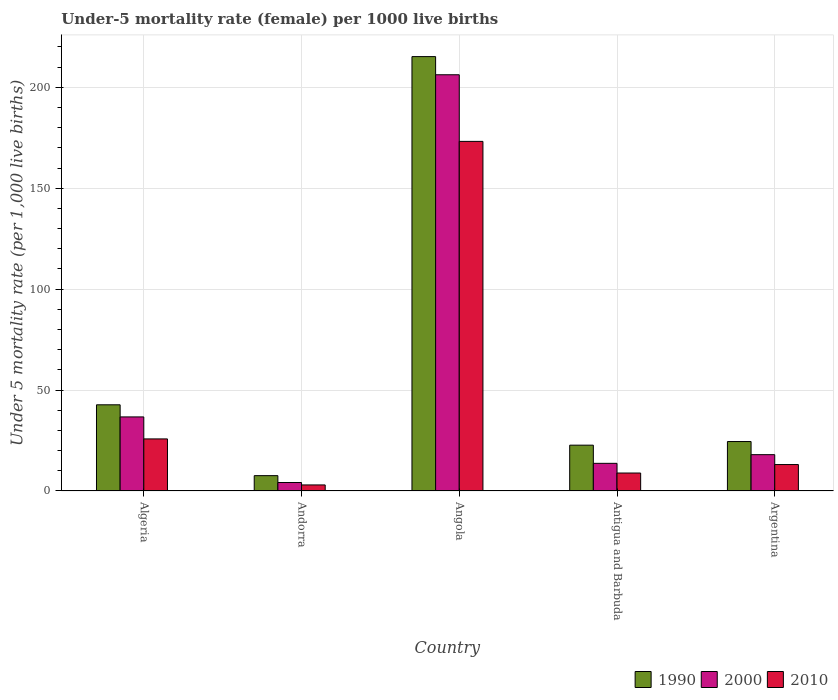How many groups of bars are there?
Provide a succinct answer. 5. How many bars are there on the 4th tick from the right?
Your response must be concise. 3. What is the label of the 3rd group of bars from the left?
Provide a short and direct response. Angola. What is the under-five mortality rate in 2000 in Angola?
Ensure brevity in your answer.  206.2. Across all countries, what is the maximum under-five mortality rate in 2000?
Make the answer very short. 206.2. Across all countries, what is the minimum under-five mortality rate in 1990?
Offer a terse response. 7.6. In which country was the under-five mortality rate in 2000 maximum?
Offer a terse response. Angola. In which country was the under-five mortality rate in 2000 minimum?
Provide a short and direct response. Andorra. What is the total under-five mortality rate in 1990 in the graph?
Provide a succinct answer. 312.7. What is the difference between the under-five mortality rate in 2010 in Andorra and that in Angola?
Your answer should be compact. -170.2. What is the difference between the under-five mortality rate in 1990 in Andorra and the under-five mortality rate in 2000 in Angola?
Keep it short and to the point. -198.6. What is the average under-five mortality rate in 2000 per country?
Keep it short and to the point. 55.76. What is the difference between the under-five mortality rate of/in 1990 and under-five mortality rate of/in 2010 in Algeria?
Your answer should be compact. 16.9. In how many countries, is the under-five mortality rate in 2010 greater than 170?
Offer a terse response. 1. What is the ratio of the under-five mortality rate in 2000 in Antigua and Barbuda to that in Argentina?
Offer a very short reply. 0.76. Is the difference between the under-five mortality rate in 1990 in Andorra and Antigua and Barbuda greater than the difference between the under-five mortality rate in 2010 in Andorra and Antigua and Barbuda?
Provide a succinct answer. No. What is the difference between the highest and the second highest under-five mortality rate in 2000?
Make the answer very short. -18.7. What is the difference between the highest and the lowest under-five mortality rate in 2010?
Your response must be concise. 170.2. Is the sum of the under-five mortality rate in 1990 in Antigua and Barbuda and Argentina greater than the maximum under-five mortality rate in 2010 across all countries?
Your response must be concise. No. What does the 1st bar from the right in Argentina represents?
Offer a terse response. 2010. Is it the case that in every country, the sum of the under-five mortality rate in 1990 and under-five mortality rate in 2010 is greater than the under-five mortality rate in 2000?
Offer a terse response. Yes. How many bars are there?
Your answer should be compact. 15. How many countries are there in the graph?
Offer a terse response. 5. Where does the legend appear in the graph?
Your answer should be very brief. Bottom right. How are the legend labels stacked?
Provide a short and direct response. Horizontal. What is the title of the graph?
Make the answer very short. Under-5 mortality rate (female) per 1000 live births. Does "1999" appear as one of the legend labels in the graph?
Provide a short and direct response. No. What is the label or title of the Y-axis?
Offer a terse response. Under 5 mortality rate (per 1,0 live births). What is the Under 5 mortality rate (per 1,000 live births) of 1990 in Algeria?
Offer a terse response. 42.7. What is the Under 5 mortality rate (per 1,000 live births) in 2000 in Algeria?
Ensure brevity in your answer.  36.7. What is the Under 5 mortality rate (per 1,000 live births) of 2010 in Algeria?
Offer a very short reply. 25.8. What is the Under 5 mortality rate (per 1,000 live births) of 1990 in Andorra?
Offer a terse response. 7.6. What is the Under 5 mortality rate (per 1,000 live births) in 2010 in Andorra?
Your answer should be compact. 3. What is the Under 5 mortality rate (per 1,000 live births) of 1990 in Angola?
Give a very brief answer. 215.2. What is the Under 5 mortality rate (per 1,000 live births) in 2000 in Angola?
Offer a terse response. 206.2. What is the Under 5 mortality rate (per 1,000 live births) in 2010 in Angola?
Your answer should be compact. 173.2. What is the Under 5 mortality rate (per 1,000 live births) in 1990 in Antigua and Barbuda?
Your response must be concise. 22.7. What is the Under 5 mortality rate (per 1,000 live births) in 2000 in Antigua and Barbuda?
Ensure brevity in your answer.  13.7. What is the Under 5 mortality rate (per 1,000 live births) of 2010 in Antigua and Barbuda?
Give a very brief answer. 8.9. What is the Under 5 mortality rate (per 1,000 live births) of 1990 in Argentina?
Provide a short and direct response. 24.5. What is the Under 5 mortality rate (per 1,000 live births) in 2000 in Argentina?
Provide a short and direct response. 18. Across all countries, what is the maximum Under 5 mortality rate (per 1,000 live births) in 1990?
Provide a succinct answer. 215.2. Across all countries, what is the maximum Under 5 mortality rate (per 1,000 live births) of 2000?
Your response must be concise. 206.2. Across all countries, what is the maximum Under 5 mortality rate (per 1,000 live births) of 2010?
Offer a terse response. 173.2. Across all countries, what is the minimum Under 5 mortality rate (per 1,000 live births) in 1990?
Provide a succinct answer. 7.6. Across all countries, what is the minimum Under 5 mortality rate (per 1,000 live births) of 2000?
Offer a terse response. 4.2. Across all countries, what is the minimum Under 5 mortality rate (per 1,000 live births) in 2010?
Your answer should be compact. 3. What is the total Under 5 mortality rate (per 1,000 live births) of 1990 in the graph?
Make the answer very short. 312.7. What is the total Under 5 mortality rate (per 1,000 live births) of 2000 in the graph?
Provide a succinct answer. 278.8. What is the total Under 5 mortality rate (per 1,000 live births) in 2010 in the graph?
Offer a very short reply. 224. What is the difference between the Under 5 mortality rate (per 1,000 live births) of 1990 in Algeria and that in Andorra?
Offer a very short reply. 35.1. What is the difference between the Under 5 mortality rate (per 1,000 live births) in 2000 in Algeria and that in Andorra?
Provide a short and direct response. 32.5. What is the difference between the Under 5 mortality rate (per 1,000 live births) in 2010 in Algeria and that in Andorra?
Your answer should be compact. 22.8. What is the difference between the Under 5 mortality rate (per 1,000 live births) of 1990 in Algeria and that in Angola?
Your answer should be very brief. -172.5. What is the difference between the Under 5 mortality rate (per 1,000 live births) of 2000 in Algeria and that in Angola?
Offer a very short reply. -169.5. What is the difference between the Under 5 mortality rate (per 1,000 live births) in 2010 in Algeria and that in Angola?
Make the answer very short. -147.4. What is the difference between the Under 5 mortality rate (per 1,000 live births) in 1990 in Algeria and that in Antigua and Barbuda?
Provide a succinct answer. 20. What is the difference between the Under 5 mortality rate (per 1,000 live births) of 2000 in Algeria and that in Antigua and Barbuda?
Offer a very short reply. 23. What is the difference between the Under 5 mortality rate (per 1,000 live births) of 1990 in Algeria and that in Argentina?
Your answer should be very brief. 18.2. What is the difference between the Under 5 mortality rate (per 1,000 live births) of 2000 in Algeria and that in Argentina?
Provide a succinct answer. 18.7. What is the difference between the Under 5 mortality rate (per 1,000 live births) of 1990 in Andorra and that in Angola?
Offer a very short reply. -207.6. What is the difference between the Under 5 mortality rate (per 1,000 live births) in 2000 in Andorra and that in Angola?
Make the answer very short. -202. What is the difference between the Under 5 mortality rate (per 1,000 live births) of 2010 in Andorra and that in Angola?
Give a very brief answer. -170.2. What is the difference between the Under 5 mortality rate (per 1,000 live births) in 1990 in Andorra and that in Antigua and Barbuda?
Offer a very short reply. -15.1. What is the difference between the Under 5 mortality rate (per 1,000 live births) of 1990 in Andorra and that in Argentina?
Keep it short and to the point. -16.9. What is the difference between the Under 5 mortality rate (per 1,000 live births) in 2000 in Andorra and that in Argentina?
Make the answer very short. -13.8. What is the difference between the Under 5 mortality rate (per 1,000 live births) of 1990 in Angola and that in Antigua and Barbuda?
Your response must be concise. 192.5. What is the difference between the Under 5 mortality rate (per 1,000 live births) of 2000 in Angola and that in Antigua and Barbuda?
Give a very brief answer. 192.5. What is the difference between the Under 5 mortality rate (per 1,000 live births) in 2010 in Angola and that in Antigua and Barbuda?
Provide a succinct answer. 164.3. What is the difference between the Under 5 mortality rate (per 1,000 live births) of 1990 in Angola and that in Argentina?
Ensure brevity in your answer.  190.7. What is the difference between the Under 5 mortality rate (per 1,000 live births) of 2000 in Angola and that in Argentina?
Your response must be concise. 188.2. What is the difference between the Under 5 mortality rate (per 1,000 live births) of 2010 in Angola and that in Argentina?
Your answer should be very brief. 160.1. What is the difference between the Under 5 mortality rate (per 1,000 live births) in 1990 in Antigua and Barbuda and that in Argentina?
Keep it short and to the point. -1.8. What is the difference between the Under 5 mortality rate (per 1,000 live births) of 2010 in Antigua and Barbuda and that in Argentina?
Your answer should be very brief. -4.2. What is the difference between the Under 5 mortality rate (per 1,000 live births) of 1990 in Algeria and the Under 5 mortality rate (per 1,000 live births) of 2000 in Andorra?
Ensure brevity in your answer.  38.5. What is the difference between the Under 5 mortality rate (per 1,000 live births) in 1990 in Algeria and the Under 5 mortality rate (per 1,000 live births) in 2010 in Andorra?
Offer a very short reply. 39.7. What is the difference between the Under 5 mortality rate (per 1,000 live births) of 2000 in Algeria and the Under 5 mortality rate (per 1,000 live births) of 2010 in Andorra?
Keep it short and to the point. 33.7. What is the difference between the Under 5 mortality rate (per 1,000 live births) in 1990 in Algeria and the Under 5 mortality rate (per 1,000 live births) in 2000 in Angola?
Ensure brevity in your answer.  -163.5. What is the difference between the Under 5 mortality rate (per 1,000 live births) in 1990 in Algeria and the Under 5 mortality rate (per 1,000 live births) in 2010 in Angola?
Ensure brevity in your answer.  -130.5. What is the difference between the Under 5 mortality rate (per 1,000 live births) in 2000 in Algeria and the Under 5 mortality rate (per 1,000 live births) in 2010 in Angola?
Provide a short and direct response. -136.5. What is the difference between the Under 5 mortality rate (per 1,000 live births) of 1990 in Algeria and the Under 5 mortality rate (per 1,000 live births) of 2010 in Antigua and Barbuda?
Your response must be concise. 33.8. What is the difference between the Under 5 mortality rate (per 1,000 live births) of 2000 in Algeria and the Under 5 mortality rate (per 1,000 live births) of 2010 in Antigua and Barbuda?
Provide a short and direct response. 27.8. What is the difference between the Under 5 mortality rate (per 1,000 live births) in 1990 in Algeria and the Under 5 mortality rate (per 1,000 live births) in 2000 in Argentina?
Your answer should be very brief. 24.7. What is the difference between the Under 5 mortality rate (per 1,000 live births) of 1990 in Algeria and the Under 5 mortality rate (per 1,000 live births) of 2010 in Argentina?
Offer a terse response. 29.6. What is the difference between the Under 5 mortality rate (per 1,000 live births) in 2000 in Algeria and the Under 5 mortality rate (per 1,000 live births) in 2010 in Argentina?
Keep it short and to the point. 23.6. What is the difference between the Under 5 mortality rate (per 1,000 live births) of 1990 in Andorra and the Under 5 mortality rate (per 1,000 live births) of 2000 in Angola?
Keep it short and to the point. -198.6. What is the difference between the Under 5 mortality rate (per 1,000 live births) in 1990 in Andorra and the Under 5 mortality rate (per 1,000 live births) in 2010 in Angola?
Give a very brief answer. -165.6. What is the difference between the Under 5 mortality rate (per 1,000 live births) in 2000 in Andorra and the Under 5 mortality rate (per 1,000 live births) in 2010 in Angola?
Your response must be concise. -169. What is the difference between the Under 5 mortality rate (per 1,000 live births) in 2000 in Andorra and the Under 5 mortality rate (per 1,000 live births) in 2010 in Antigua and Barbuda?
Your answer should be very brief. -4.7. What is the difference between the Under 5 mortality rate (per 1,000 live births) of 1990 in Andorra and the Under 5 mortality rate (per 1,000 live births) of 2000 in Argentina?
Make the answer very short. -10.4. What is the difference between the Under 5 mortality rate (per 1,000 live births) of 1990 in Andorra and the Under 5 mortality rate (per 1,000 live births) of 2010 in Argentina?
Provide a short and direct response. -5.5. What is the difference between the Under 5 mortality rate (per 1,000 live births) of 1990 in Angola and the Under 5 mortality rate (per 1,000 live births) of 2000 in Antigua and Barbuda?
Make the answer very short. 201.5. What is the difference between the Under 5 mortality rate (per 1,000 live births) of 1990 in Angola and the Under 5 mortality rate (per 1,000 live births) of 2010 in Antigua and Barbuda?
Offer a terse response. 206.3. What is the difference between the Under 5 mortality rate (per 1,000 live births) in 2000 in Angola and the Under 5 mortality rate (per 1,000 live births) in 2010 in Antigua and Barbuda?
Keep it short and to the point. 197.3. What is the difference between the Under 5 mortality rate (per 1,000 live births) of 1990 in Angola and the Under 5 mortality rate (per 1,000 live births) of 2000 in Argentina?
Keep it short and to the point. 197.2. What is the difference between the Under 5 mortality rate (per 1,000 live births) of 1990 in Angola and the Under 5 mortality rate (per 1,000 live births) of 2010 in Argentina?
Your response must be concise. 202.1. What is the difference between the Under 5 mortality rate (per 1,000 live births) in 2000 in Angola and the Under 5 mortality rate (per 1,000 live births) in 2010 in Argentina?
Your answer should be compact. 193.1. What is the difference between the Under 5 mortality rate (per 1,000 live births) in 1990 in Antigua and Barbuda and the Under 5 mortality rate (per 1,000 live births) in 2000 in Argentina?
Provide a succinct answer. 4.7. What is the difference between the Under 5 mortality rate (per 1,000 live births) of 1990 in Antigua and Barbuda and the Under 5 mortality rate (per 1,000 live births) of 2010 in Argentina?
Offer a very short reply. 9.6. What is the difference between the Under 5 mortality rate (per 1,000 live births) in 2000 in Antigua and Barbuda and the Under 5 mortality rate (per 1,000 live births) in 2010 in Argentina?
Offer a very short reply. 0.6. What is the average Under 5 mortality rate (per 1,000 live births) of 1990 per country?
Offer a terse response. 62.54. What is the average Under 5 mortality rate (per 1,000 live births) of 2000 per country?
Your response must be concise. 55.76. What is the average Under 5 mortality rate (per 1,000 live births) in 2010 per country?
Offer a terse response. 44.8. What is the difference between the Under 5 mortality rate (per 1,000 live births) in 1990 and Under 5 mortality rate (per 1,000 live births) in 2000 in Algeria?
Provide a short and direct response. 6. What is the difference between the Under 5 mortality rate (per 1,000 live births) of 1990 and Under 5 mortality rate (per 1,000 live births) of 2000 in Andorra?
Provide a short and direct response. 3.4. What is the difference between the Under 5 mortality rate (per 1,000 live births) in 1990 and Under 5 mortality rate (per 1,000 live births) in 2010 in Andorra?
Provide a succinct answer. 4.6. What is the difference between the Under 5 mortality rate (per 1,000 live births) in 2000 and Under 5 mortality rate (per 1,000 live births) in 2010 in Andorra?
Make the answer very short. 1.2. What is the difference between the Under 5 mortality rate (per 1,000 live births) in 1990 and Under 5 mortality rate (per 1,000 live births) in 2000 in Angola?
Your response must be concise. 9. What is the difference between the Under 5 mortality rate (per 1,000 live births) of 1990 and Under 5 mortality rate (per 1,000 live births) of 2010 in Angola?
Your answer should be very brief. 42. What is the difference between the Under 5 mortality rate (per 1,000 live births) of 2000 and Under 5 mortality rate (per 1,000 live births) of 2010 in Angola?
Give a very brief answer. 33. What is the difference between the Under 5 mortality rate (per 1,000 live births) in 1990 and Under 5 mortality rate (per 1,000 live births) in 2000 in Antigua and Barbuda?
Your answer should be compact. 9. What is the ratio of the Under 5 mortality rate (per 1,000 live births) in 1990 in Algeria to that in Andorra?
Provide a short and direct response. 5.62. What is the ratio of the Under 5 mortality rate (per 1,000 live births) in 2000 in Algeria to that in Andorra?
Provide a short and direct response. 8.74. What is the ratio of the Under 5 mortality rate (per 1,000 live births) of 2010 in Algeria to that in Andorra?
Give a very brief answer. 8.6. What is the ratio of the Under 5 mortality rate (per 1,000 live births) in 1990 in Algeria to that in Angola?
Provide a succinct answer. 0.2. What is the ratio of the Under 5 mortality rate (per 1,000 live births) in 2000 in Algeria to that in Angola?
Give a very brief answer. 0.18. What is the ratio of the Under 5 mortality rate (per 1,000 live births) in 2010 in Algeria to that in Angola?
Give a very brief answer. 0.15. What is the ratio of the Under 5 mortality rate (per 1,000 live births) in 1990 in Algeria to that in Antigua and Barbuda?
Provide a short and direct response. 1.88. What is the ratio of the Under 5 mortality rate (per 1,000 live births) in 2000 in Algeria to that in Antigua and Barbuda?
Your answer should be very brief. 2.68. What is the ratio of the Under 5 mortality rate (per 1,000 live births) in 2010 in Algeria to that in Antigua and Barbuda?
Provide a succinct answer. 2.9. What is the ratio of the Under 5 mortality rate (per 1,000 live births) of 1990 in Algeria to that in Argentina?
Offer a very short reply. 1.74. What is the ratio of the Under 5 mortality rate (per 1,000 live births) of 2000 in Algeria to that in Argentina?
Provide a short and direct response. 2.04. What is the ratio of the Under 5 mortality rate (per 1,000 live births) of 2010 in Algeria to that in Argentina?
Give a very brief answer. 1.97. What is the ratio of the Under 5 mortality rate (per 1,000 live births) in 1990 in Andorra to that in Angola?
Provide a short and direct response. 0.04. What is the ratio of the Under 5 mortality rate (per 1,000 live births) of 2000 in Andorra to that in Angola?
Your answer should be compact. 0.02. What is the ratio of the Under 5 mortality rate (per 1,000 live births) of 2010 in Andorra to that in Angola?
Ensure brevity in your answer.  0.02. What is the ratio of the Under 5 mortality rate (per 1,000 live births) in 1990 in Andorra to that in Antigua and Barbuda?
Make the answer very short. 0.33. What is the ratio of the Under 5 mortality rate (per 1,000 live births) of 2000 in Andorra to that in Antigua and Barbuda?
Make the answer very short. 0.31. What is the ratio of the Under 5 mortality rate (per 1,000 live births) in 2010 in Andorra to that in Antigua and Barbuda?
Your answer should be compact. 0.34. What is the ratio of the Under 5 mortality rate (per 1,000 live births) of 1990 in Andorra to that in Argentina?
Your answer should be compact. 0.31. What is the ratio of the Under 5 mortality rate (per 1,000 live births) of 2000 in Andorra to that in Argentina?
Offer a terse response. 0.23. What is the ratio of the Under 5 mortality rate (per 1,000 live births) in 2010 in Andorra to that in Argentina?
Provide a succinct answer. 0.23. What is the ratio of the Under 5 mortality rate (per 1,000 live births) in 1990 in Angola to that in Antigua and Barbuda?
Provide a short and direct response. 9.48. What is the ratio of the Under 5 mortality rate (per 1,000 live births) in 2000 in Angola to that in Antigua and Barbuda?
Your answer should be compact. 15.05. What is the ratio of the Under 5 mortality rate (per 1,000 live births) of 2010 in Angola to that in Antigua and Barbuda?
Provide a short and direct response. 19.46. What is the ratio of the Under 5 mortality rate (per 1,000 live births) of 1990 in Angola to that in Argentina?
Offer a terse response. 8.78. What is the ratio of the Under 5 mortality rate (per 1,000 live births) in 2000 in Angola to that in Argentina?
Ensure brevity in your answer.  11.46. What is the ratio of the Under 5 mortality rate (per 1,000 live births) in 2010 in Angola to that in Argentina?
Ensure brevity in your answer.  13.22. What is the ratio of the Under 5 mortality rate (per 1,000 live births) in 1990 in Antigua and Barbuda to that in Argentina?
Keep it short and to the point. 0.93. What is the ratio of the Under 5 mortality rate (per 1,000 live births) in 2000 in Antigua and Barbuda to that in Argentina?
Your answer should be compact. 0.76. What is the ratio of the Under 5 mortality rate (per 1,000 live births) of 2010 in Antigua and Barbuda to that in Argentina?
Provide a succinct answer. 0.68. What is the difference between the highest and the second highest Under 5 mortality rate (per 1,000 live births) of 1990?
Offer a terse response. 172.5. What is the difference between the highest and the second highest Under 5 mortality rate (per 1,000 live births) in 2000?
Offer a very short reply. 169.5. What is the difference between the highest and the second highest Under 5 mortality rate (per 1,000 live births) of 2010?
Keep it short and to the point. 147.4. What is the difference between the highest and the lowest Under 5 mortality rate (per 1,000 live births) in 1990?
Give a very brief answer. 207.6. What is the difference between the highest and the lowest Under 5 mortality rate (per 1,000 live births) in 2000?
Keep it short and to the point. 202. What is the difference between the highest and the lowest Under 5 mortality rate (per 1,000 live births) of 2010?
Your response must be concise. 170.2. 